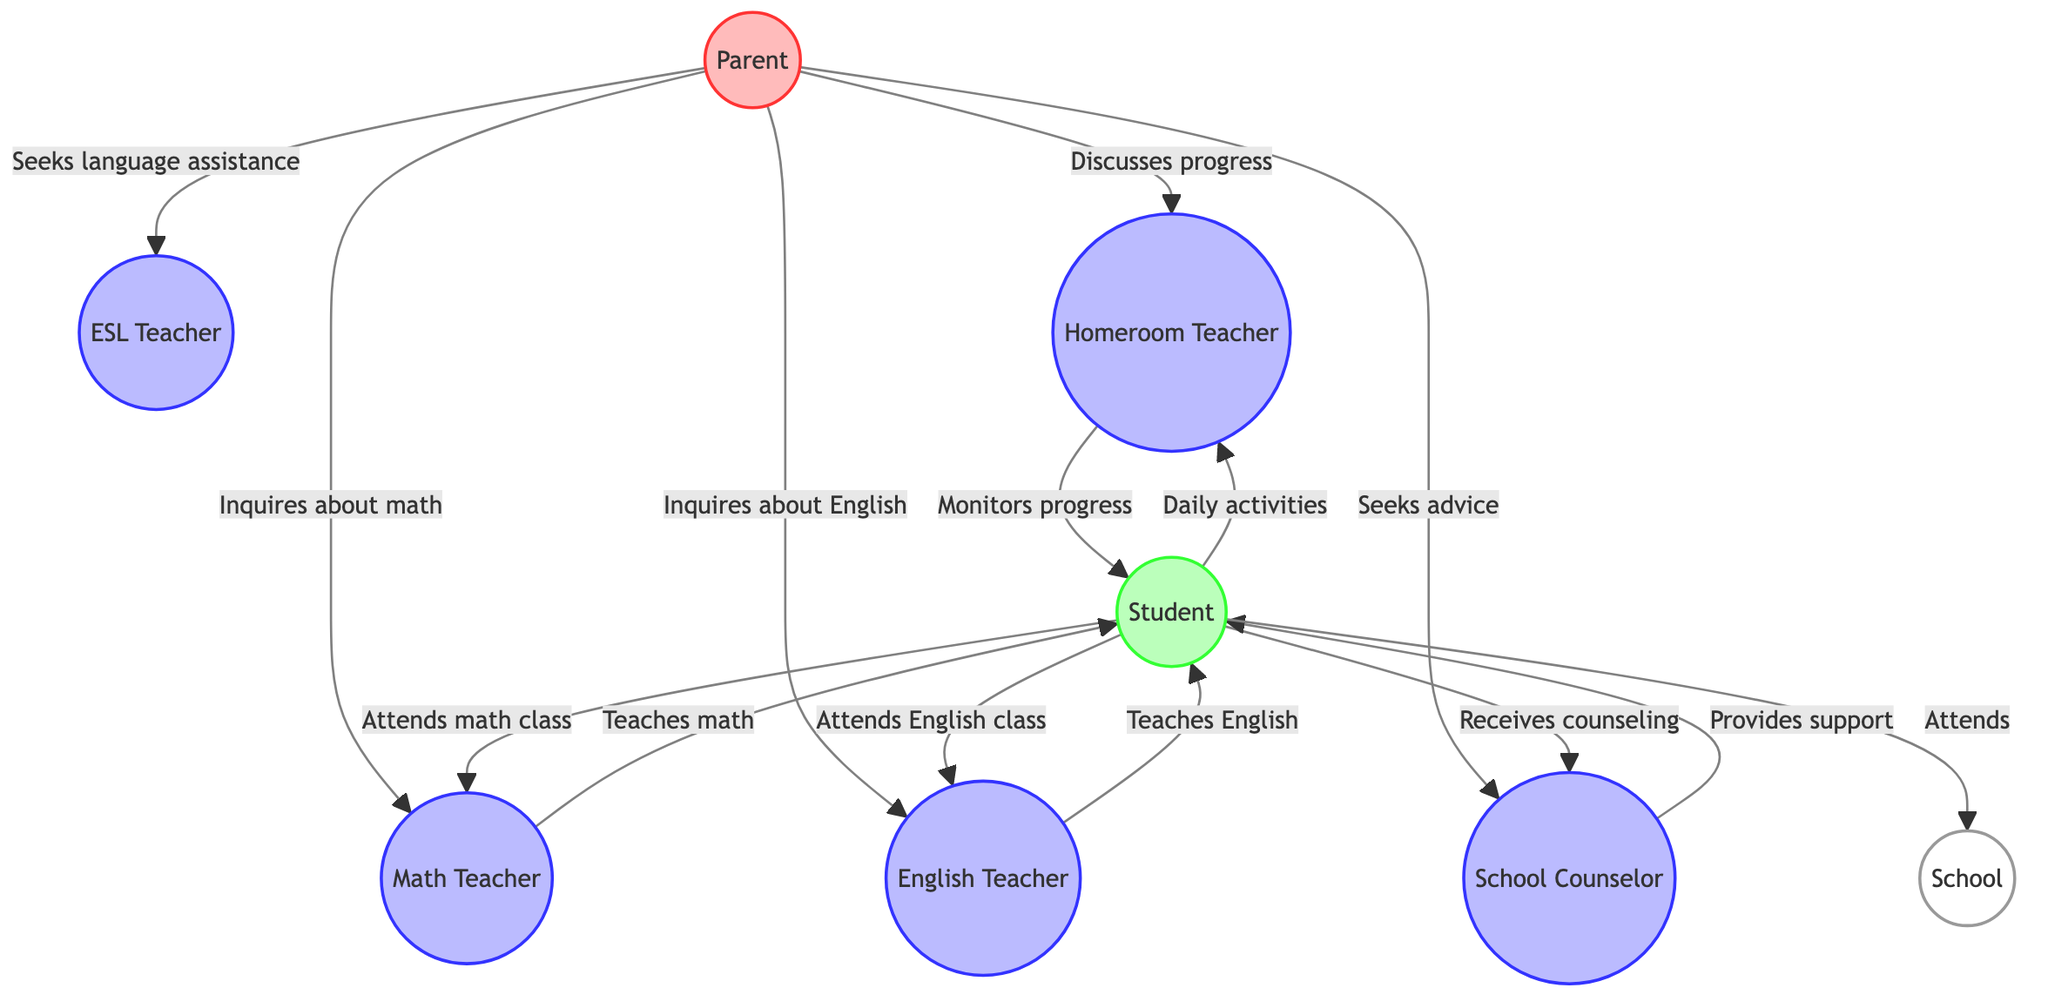What are the main roles depicted in the diagram? The diagram shows nodes representing the Parent, ESL Teacher, Homeroom Teacher, Math Teacher, English Teacher, Student, School Counselor, and School. Each node represents a different role in the communication web.
Answer: Parent, ESL Teacher, Homeroom Teacher, Math Teacher, English Teacher, Student, School Counselor, School How many edges are present in the diagram? Counting all the lines connecting the nodes, there are 13 edges in total showing the relationships between the different roles involved in academic updates.
Answer: 13 What is the relationship between the Parent and the English Teacher? The Parent inquires about the performance of the Student in English class, establishing a direct connection to the English Teacher for academic updates.
Answer: Inquires about performance in English class Who provides emotional support to the Student? The School Counselor is the role that provides emotional support to the Student, as indicated by the edge connecting these two nodes.
Answer: School Counselor How many teachers are involved in the communication web? There are four teachers represented in the diagram: ESL Teacher, Homeroom Teacher, Math Teacher, and English Teacher, each playing specific roles in supporting the Student.
Answer: Four What does the Parent seek from the ESL Teacher? The Parent seeks assistance with the English language, which indicates a need for language support in communicating academically.
Answer: Seeks language assistance Whom does the Student interact with to discuss daily activities? The Student interacts with the Homeroom Teacher to discuss daily school activities and overall well-being, as shown in the diagram.
Answer: Homeroom Teacher Which role is responsible for monitoring the Student's overall progress? The Homeroom Teacher is responsible for monitoring the Student's overall progress, as indicated by the edge connecting them where the Homeroom Teacher monitors the Student.
Answer: Homeroom Teacher What type of support does the School Counselor provide to the Student? The School Counselor provides both academic and emotional support to the Student, as reflected in the diagram's connections between them.
Answer: Provides academic and emotional support 